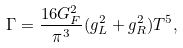Convert formula to latex. <formula><loc_0><loc_0><loc_500><loc_500>\Gamma = \frac { 1 6 G _ { F } ^ { 2 } } { \pi ^ { 3 } } ( g _ { L } ^ { 2 } + g _ { R } ^ { 2 } ) T ^ { 5 } ,</formula> 